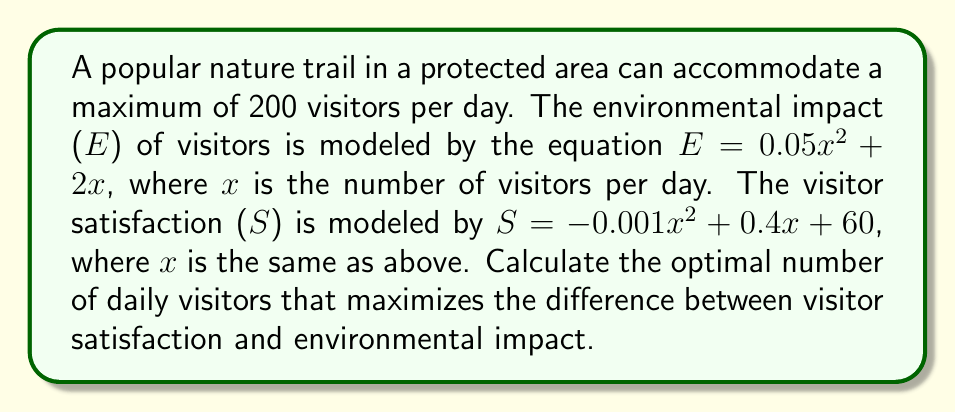Can you solve this math problem? To find the optimal number of visitors, we need to maximize the difference between visitor satisfaction and environmental impact. Let's call this difference D.

1) Express D as a function of x:
   $$D(x) = S(x) - E(x) = (-0.001x^2 + 0.4x + 60) - (0.05x^2 + 2x)$$
   $$D(x) = -0.051x^2 - 1.6x + 60$$

2) To find the maximum of D(x), we need to find where its derivative equals zero:
   $$D'(x) = -0.102x - 1.6$$

3) Set D'(x) = 0 and solve for x:
   $$-0.102x - 1.6 = 0$$
   $$-0.102x = 1.6$$
   $$x = -15.686$$

4) The second derivative $D''(x) = -0.102$ is negative, confirming this is a maximum.

5) Since x represents the number of visitors, it must be positive. The closest positive integer to our solution that's within the trail's capacity is 16.

6) To verify, we can calculate D(15) and D(16):
   D(15) = -0.051(15^2) - 1.6(15) + 60 = 26.575
   D(16) = -0.051(16^2) - 1.6(16) + 60 = 26.576

Therefore, the optimal number of daily visitors is 16.
Answer: 16 visitors 